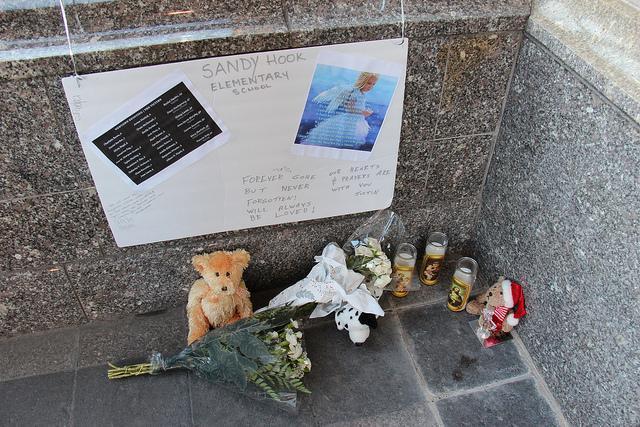How many teddy bears are there?
Give a very brief answer. 2. 